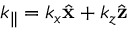Convert formula to latex. <formula><loc_0><loc_0><loc_500><loc_500>{ \boldsymbol k _ { \| } } = k _ { x } \hat { x } + k _ { z } \hat { z }</formula> 